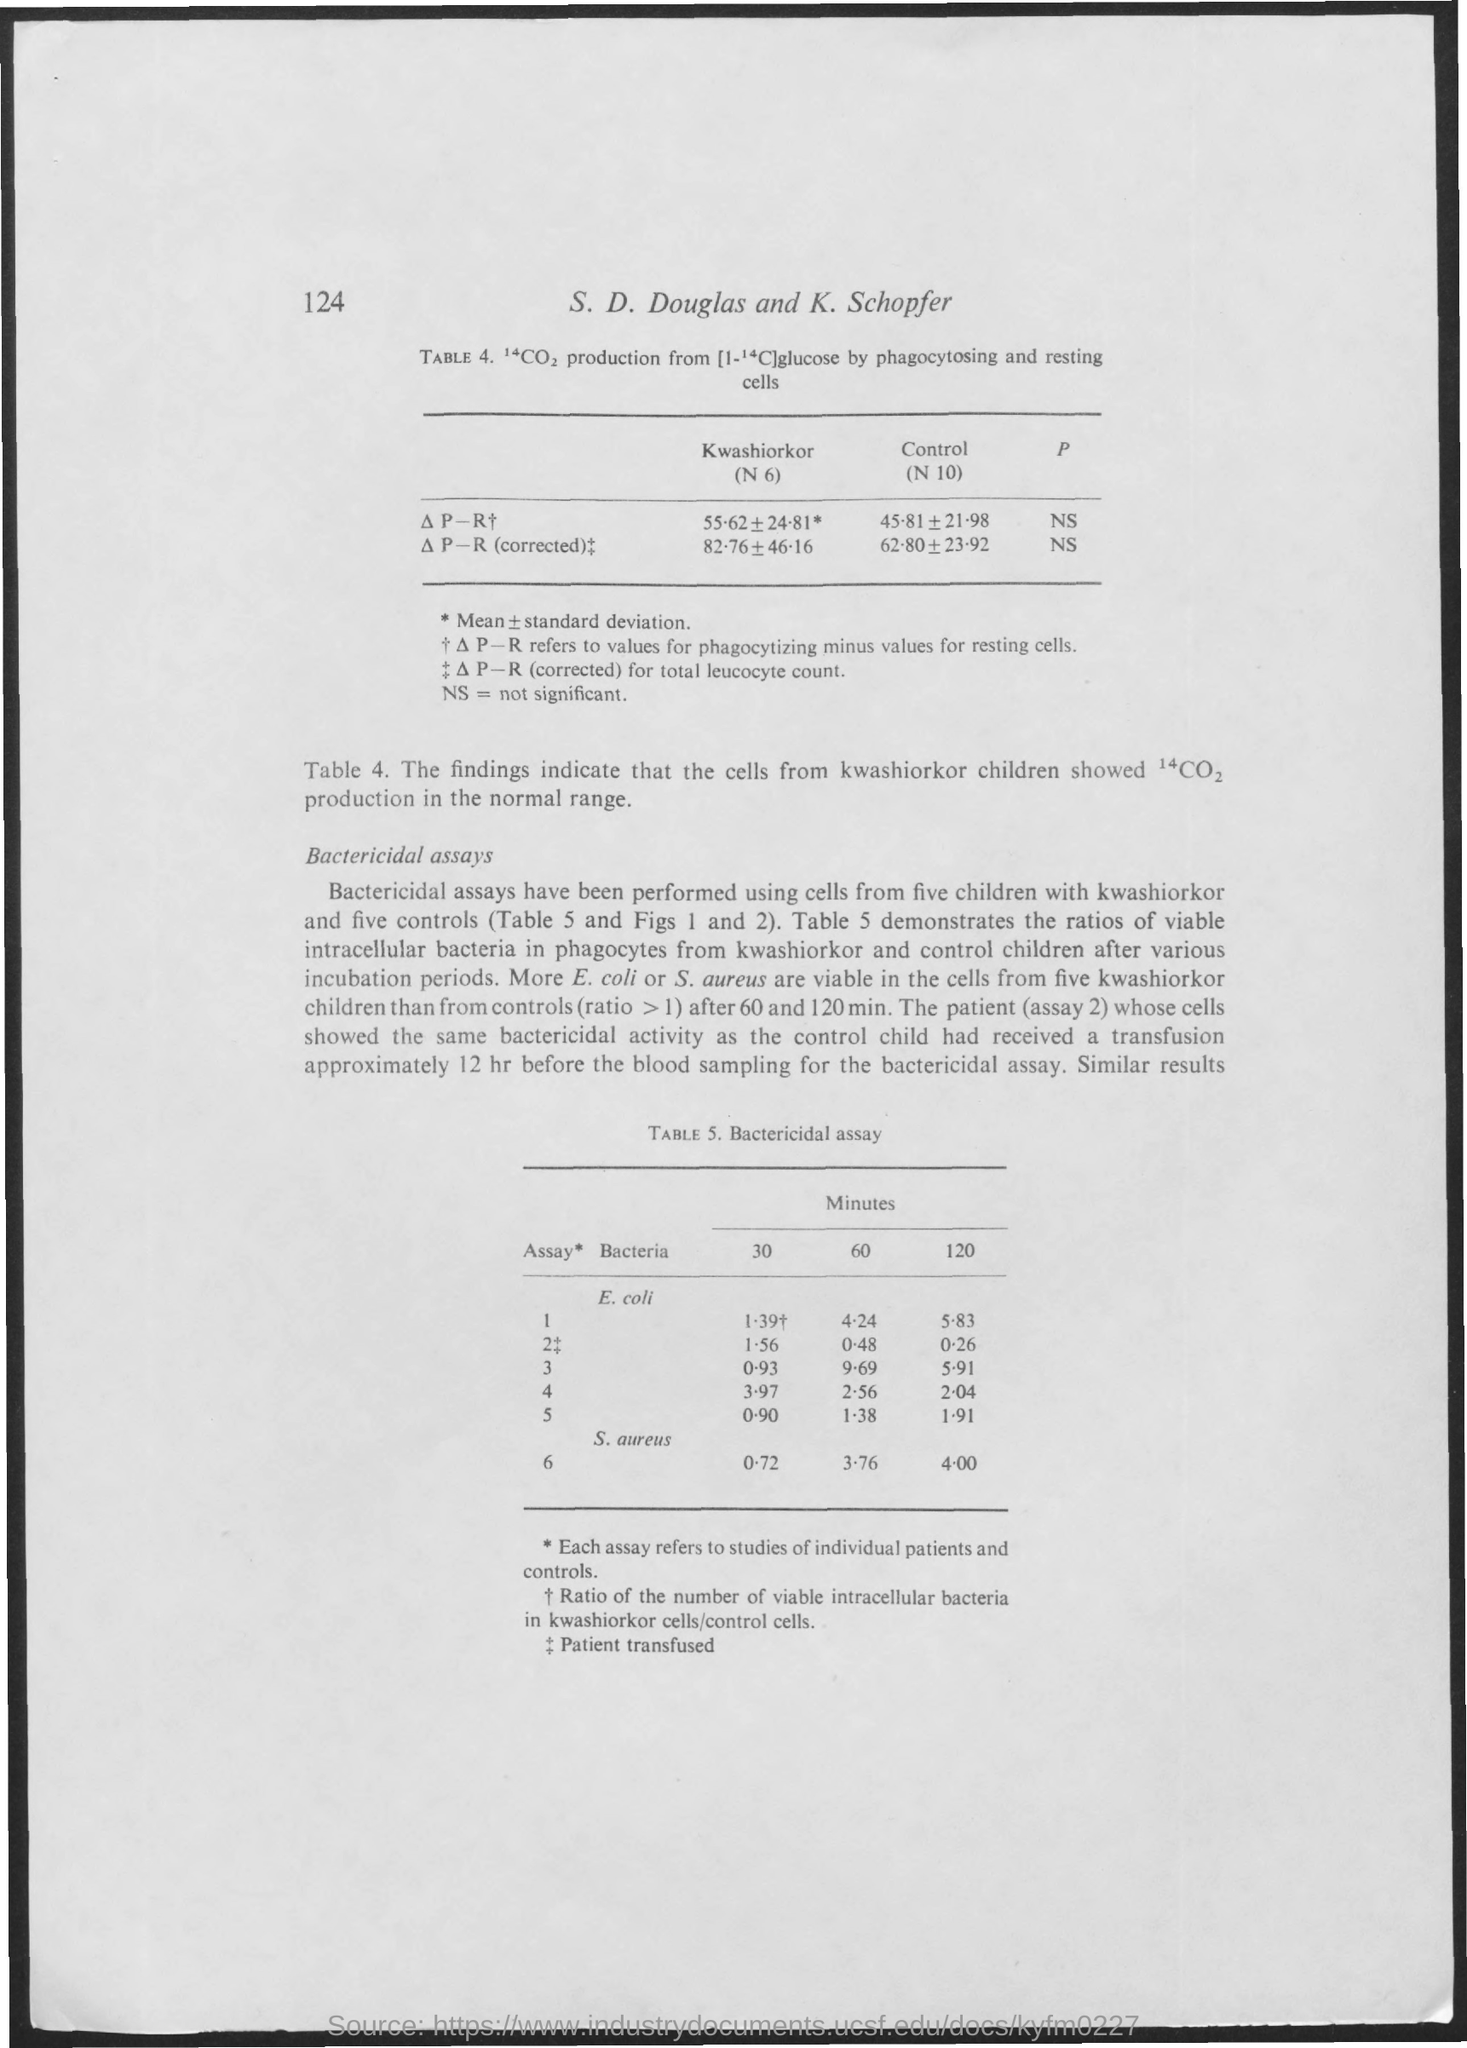Which number is at the top left of the document?
Offer a terse response. 124. What is the first table number?
Offer a very short reply. 4. What is the first title in the document?
Your answer should be very brief. S. D. Douglas and K. Schopfer. What is the full form of NS?
Your response must be concise. Not significant. What is the second table number?
Give a very brief answer. Table 5. 